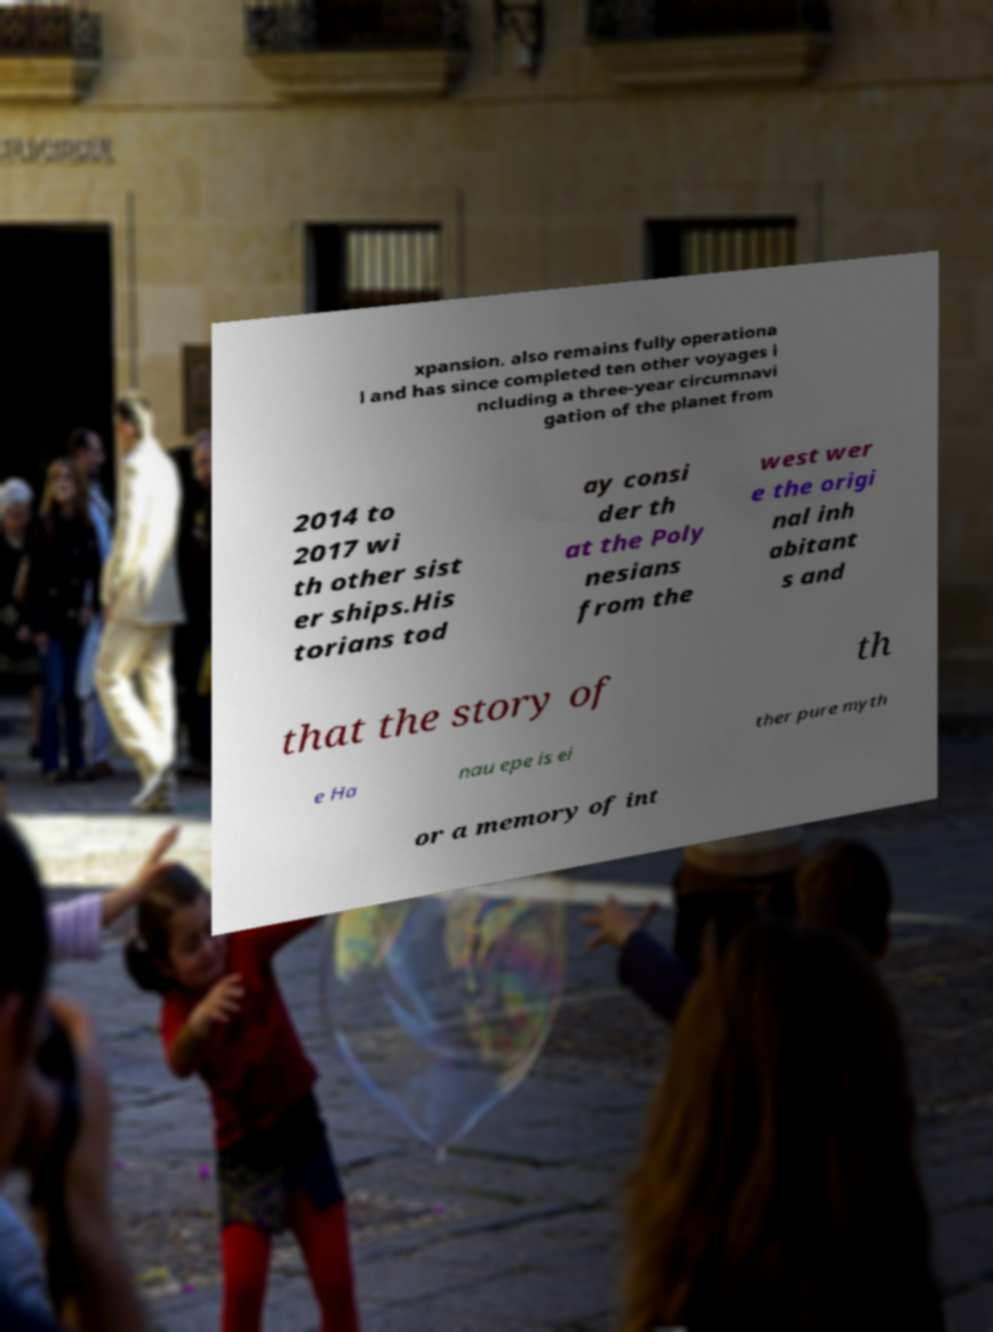What messages or text are displayed in this image? I need them in a readable, typed format. xpansion. also remains fully operationa l and has since completed ten other voyages i ncluding a three-year circumnavi gation of the planet from 2014 to 2017 wi th other sist er ships.His torians tod ay consi der th at the Poly nesians from the west wer e the origi nal inh abitant s and that the story of th e Ha nau epe is ei ther pure myth or a memory of int 